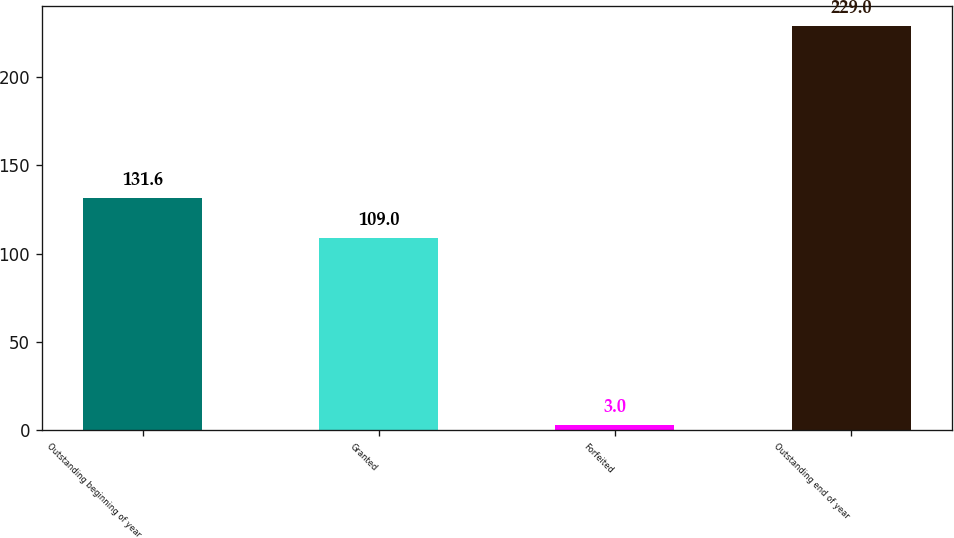<chart> <loc_0><loc_0><loc_500><loc_500><bar_chart><fcel>Outstanding beginning of year<fcel>Granted<fcel>Forfeited<fcel>Outstanding end of year<nl><fcel>131.6<fcel>109<fcel>3<fcel>229<nl></chart> 